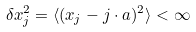Convert formula to latex. <formula><loc_0><loc_0><loc_500><loc_500>\delta x _ { j } ^ { 2 } = \langle ( x _ { j } - j \cdot a ) ^ { 2 } \rangle < \infty</formula> 